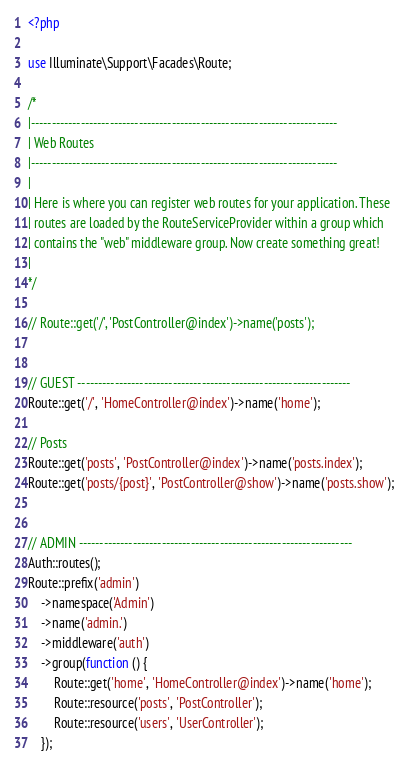<code> <loc_0><loc_0><loc_500><loc_500><_PHP_><?php

use Illuminate\Support\Facades\Route;

/*
|--------------------------------------------------------------------------
| Web Routes
|--------------------------------------------------------------------------
|
| Here is where you can register web routes for your application. These
| routes are loaded by the RouteServiceProvider within a group which
| contains the "web" middleware group. Now create something great!
|
*/

// Route::get('/', 'PostController@index')->name('posts');


// GUEST ------------------------------------------------------------------
Route::get('/', 'HomeController@index')->name('home');

// Posts
Route::get('posts', 'PostController@index')->name('posts.index');
Route::get('posts/{post}', 'PostController@show')->name('posts.show');


// ADMIN ------------------------------------------------------------------
Auth::routes();
Route::prefix('admin')
    ->namespace('Admin')
    ->name('admin.')
    ->middleware('auth')
    ->group(function () {
        Route::get('home', 'HomeController@index')->name('home');
        Route::resource('posts', 'PostController');
        Route::resource('users', 'UserController');
    });
</code> 